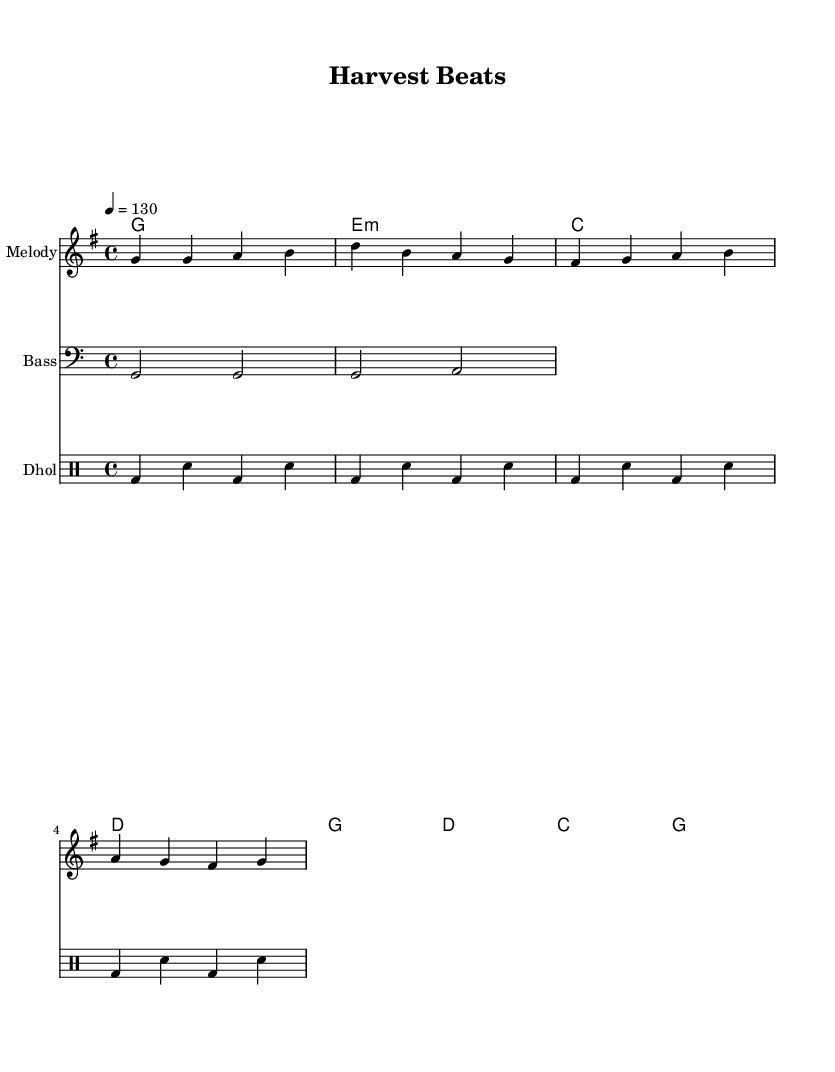What is the key signature of this music? The key signature is G major, which has one sharp (F#). This can be identified by looking at the key signature shown at the beginning of the staff.
Answer: G major What is the time signature of the piece? The time signature is 4/4, which indicates there are four beats per measure and a quarter note gets one beat. This is explicitly noted in the music notation.
Answer: 4/4 What is the tempo marking of this score? The tempo marking indicates a speed of 130 beats per minute, which refers to how fast the music should be played. This is stated in the tempo instruction within the global settings.
Answer: 130 How many measures are in the melody section? There are eight measures in the melody section, which can be counted by visually observing the measures divided by vertical lines in the staff.
Answer: 8 What type of rhythm pattern is used in the dhol section? The dhol section uses a repetitive pattern consisting of a bass drum followed by a snare. This can be seen by analyzing the dhol notation, which repeats the same rhythmic motif multiple times.
Answer: Repetitive pattern Which instrument is notated in the bass clef? The bass part is notated in the bass clef, as indicated by the clef symbol at the beginning of the bass staff. This aligns with standard notation practices where lower-register instruments use the bass clef.
Answer: Bass What is the first chord in the harmony section? The first chord in the harmony section is G major, which is indicated at the start of the chord chord mode. The name of the chord visually appears above the first measure.
Answer: G major 